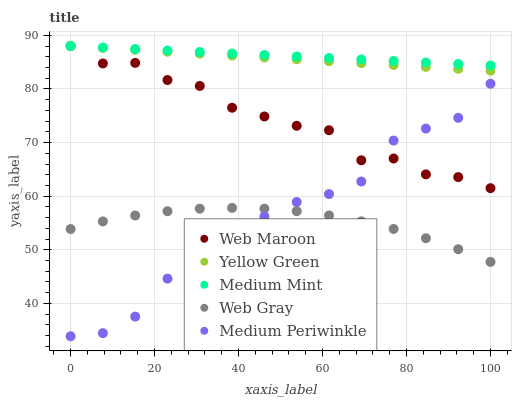Does Web Gray have the minimum area under the curve?
Answer yes or no. Yes. Does Medium Mint have the maximum area under the curve?
Answer yes or no. Yes. Does Medium Periwinkle have the minimum area under the curve?
Answer yes or no. No. Does Medium Periwinkle have the maximum area under the curve?
Answer yes or no. No. Is Yellow Green the smoothest?
Answer yes or no. Yes. Is Medium Periwinkle the roughest?
Answer yes or no. Yes. Is Web Gray the smoothest?
Answer yes or no. No. Is Web Gray the roughest?
Answer yes or no. No. Does Medium Periwinkle have the lowest value?
Answer yes or no. Yes. Does Web Gray have the lowest value?
Answer yes or no. No. Does Yellow Green have the highest value?
Answer yes or no. Yes. Does Medium Periwinkle have the highest value?
Answer yes or no. No. Is Medium Periwinkle less than Medium Mint?
Answer yes or no. Yes. Is Medium Mint greater than Medium Periwinkle?
Answer yes or no. Yes. Does Medium Periwinkle intersect Web Gray?
Answer yes or no. Yes. Is Medium Periwinkle less than Web Gray?
Answer yes or no. No. Is Medium Periwinkle greater than Web Gray?
Answer yes or no. No. Does Medium Periwinkle intersect Medium Mint?
Answer yes or no. No. 